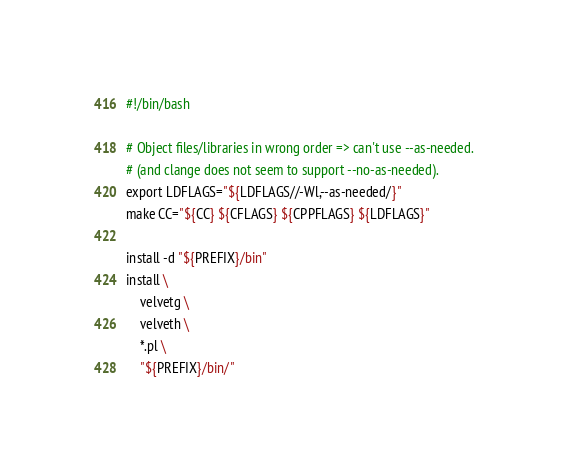<code> <loc_0><loc_0><loc_500><loc_500><_Bash_>#!/bin/bash

# Object files/libraries in wrong order => can't use --as-needed.
# (and clange does not seem to support --no-as-needed).
export LDFLAGS="${LDFLAGS//-Wl,--as-needed/}"
make CC="${CC} ${CFLAGS} ${CPPFLAGS} ${LDFLAGS}"

install -d "${PREFIX}/bin"
install \
    velvetg \
    velveth \
    *.pl \
    "${PREFIX}/bin/"
</code> 